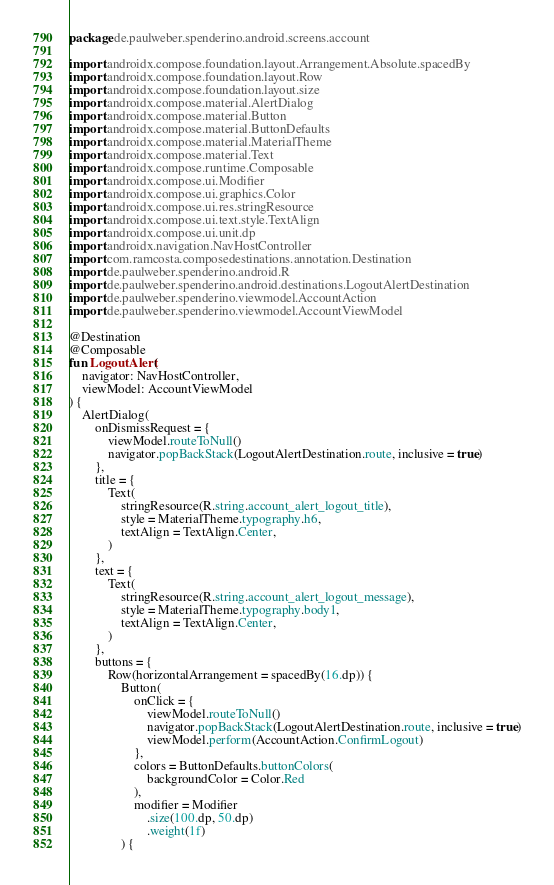<code> <loc_0><loc_0><loc_500><loc_500><_Kotlin_>package de.paulweber.spenderino.android.screens.account

import androidx.compose.foundation.layout.Arrangement.Absolute.spacedBy
import androidx.compose.foundation.layout.Row
import androidx.compose.foundation.layout.size
import androidx.compose.material.AlertDialog
import androidx.compose.material.Button
import androidx.compose.material.ButtonDefaults
import androidx.compose.material.MaterialTheme
import androidx.compose.material.Text
import androidx.compose.runtime.Composable
import androidx.compose.ui.Modifier
import androidx.compose.ui.graphics.Color
import androidx.compose.ui.res.stringResource
import androidx.compose.ui.text.style.TextAlign
import androidx.compose.ui.unit.dp
import androidx.navigation.NavHostController
import com.ramcosta.composedestinations.annotation.Destination
import de.paulweber.spenderino.android.R
import de.paulweber.spenderino.android.destinations.LogoutAlertDestination
import de.paulweber.spenderino.viewmodel.AccountAction
import de.paulweber.spenderino.viewmodel.AccountViewModel

@Destination
@Composable
fun LogoutAlert(
    navigator: NavHostController,
    viewModel: AccountViewModel
) {
    AlertDialog(
        onDismissRequest = {
            viewModel.routeToNull()
            navigator.popBackStack(LogoutAlertDestination.route, inclusive = true)
        },
        title = {
            Text(
                stringResource(R.string.account_alert_logout_title),
                style = MaterialTheme.typography.h6,
                textAlign = TextAlign.Center,
            )
        },
        text = {
            Text(
                stringResource(R.string.account_alert_logout_message),
                style = MaterialTheme.typography.body1,
                textAlign = TextAlign.Center,
            )
        },
        buttons = {
            Row(horizontalArrangement = spacedBy(16.dp)) {
                Button(
                    onClick = {
                        viewModel.routeToNull()
                        navigator.popBackStack(LogoutAlertDestination.route, inclusive = true)
                        viewModel.perform(AccountAction.ConfirmLogout)
                    },
                    colors = ButtonDefaults.buttonColors(
                        backgroundColor = Color.Red
                    ),
                    modifier = Modifier
                        .size(100.dp, 50.dp)
                        .weight(1f)
                ) {</code> 